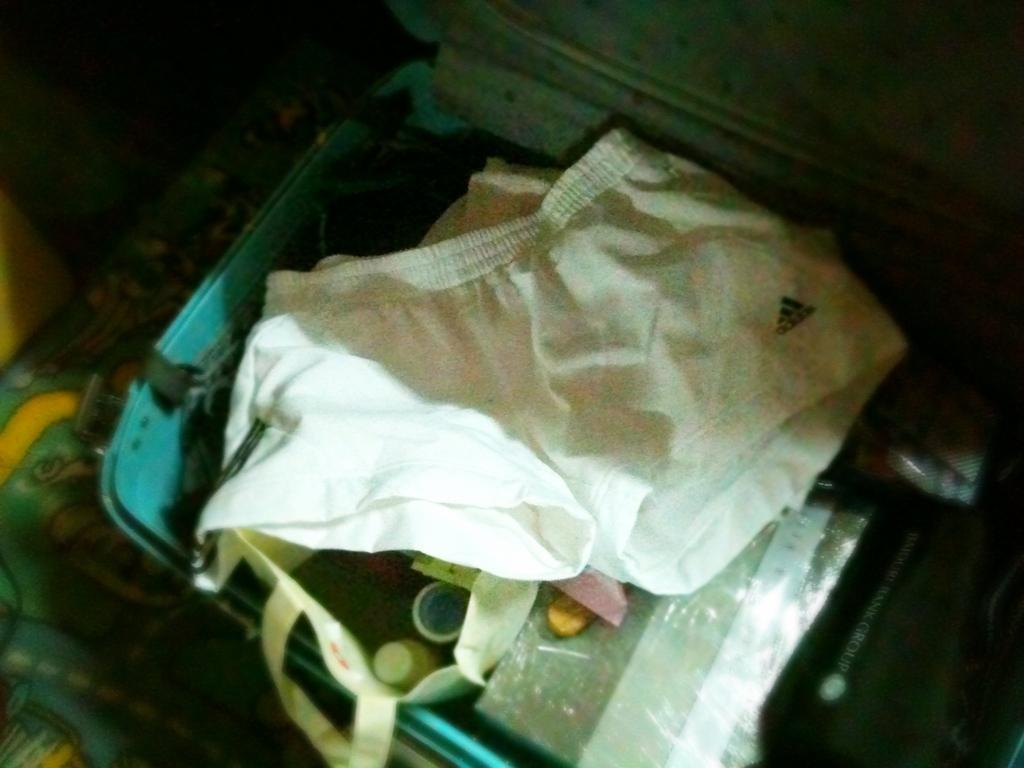What color is the cloth that is visible in the image? The cloth in the image is white. What is inside the suitcase that is visible in the image? There are objects in a suitcase in the image. How would you describe the overall lighting in the image? The background of the image is dark. What type of disease is being treated in the image? There is no indication of a disease or medical treatment in the image. What addition has been made to the roof in the image? There is no roof or any mention of an addition in the image. 